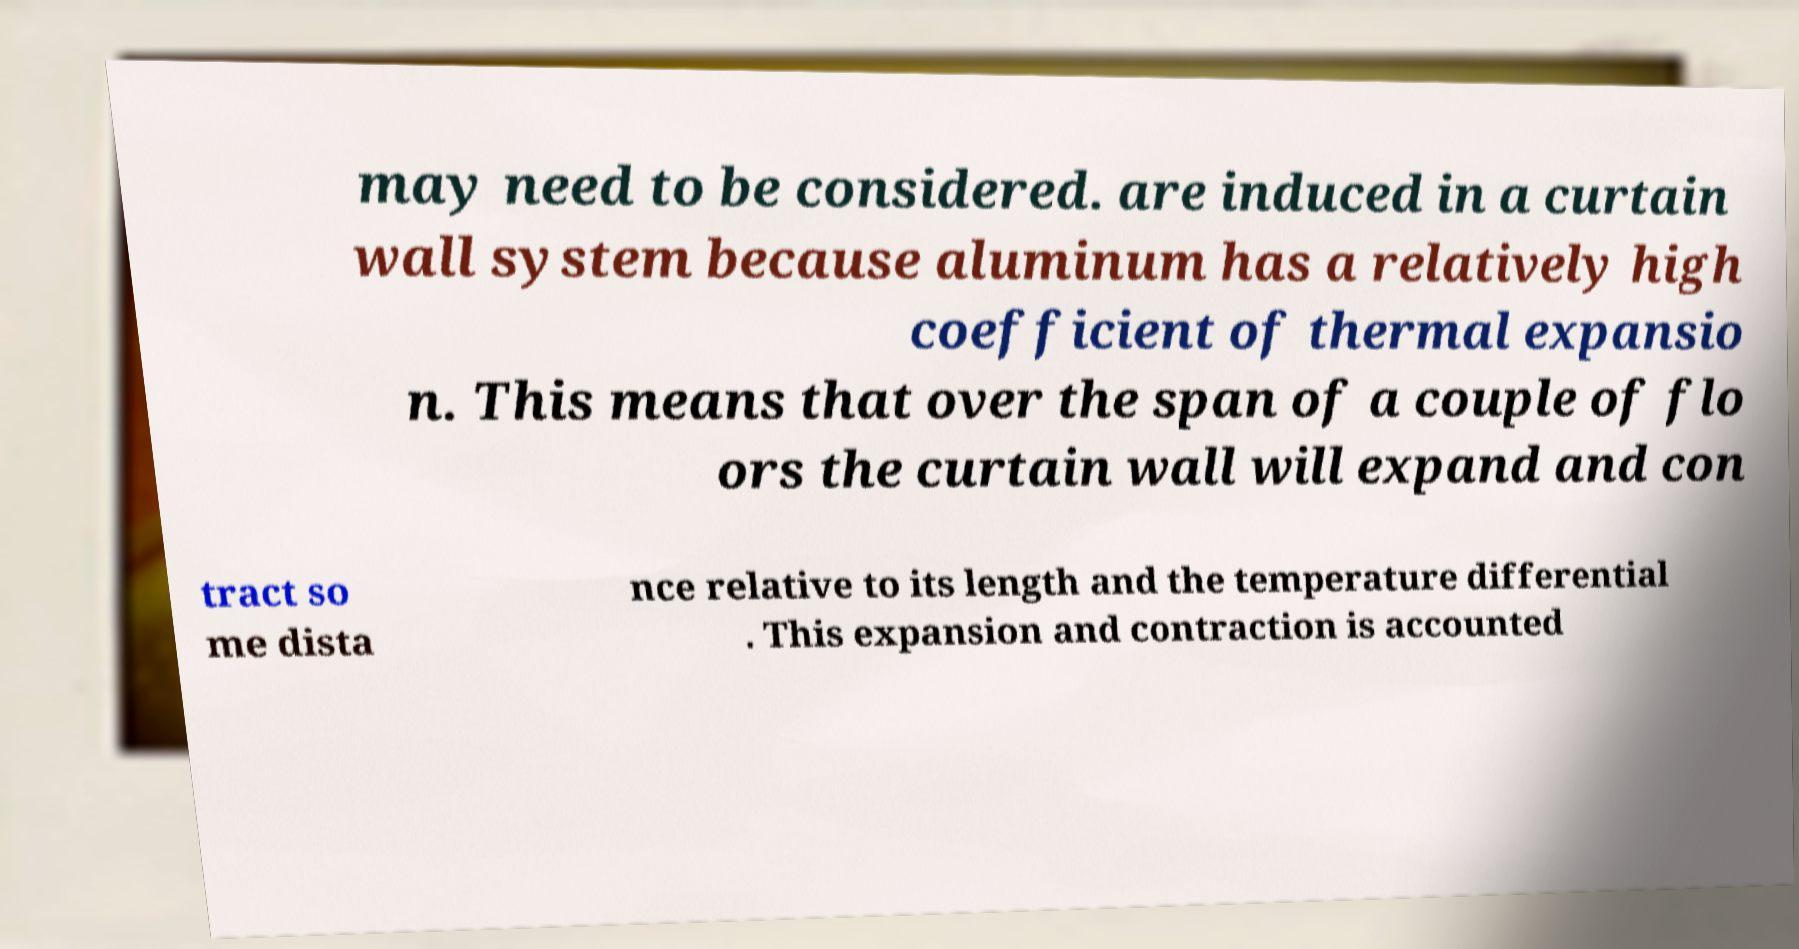Can you read and provide the text displayed in the image?This photo seems to have some interesting text. Can you extract and type it out for me? may need to be considered. are induced in a curtain wall system because aluminum has a relatively high coefficient of thermal expansio n. This means that over the span of a couple of flo ors the curtain wall will expand and con tract so me dista nce relative to its length and the temperature differential . This expansion and contraction is accounted 